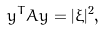Convert formula to latex. <formula><loc_0><loc_0><loc_500><loc_500>y ^ { T } A y = | \xi | ^ { 2 } ,</formula> 